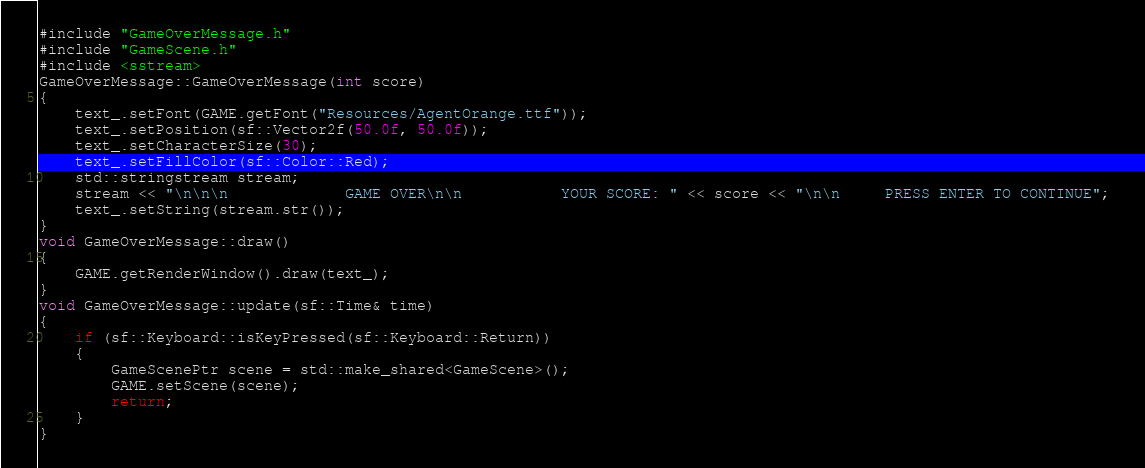<code> <loc_0><loc_0><loc_500><loc_500><_C++_>#include "GameOverMessage.h"
#include "GameScene.h"
#include <sstream>
GameOverMessage::GameOverMessage(int score)
{
	text_.setFont(GAME.getFont("Resources/AgentOrange.ttf"));
	text_.setPosition(sf::Vector2f(50.0f, 50.0f));
	text_.setCharacterSize(30);
	text_.setFillColor(sf::Color::Red);
	std::stringstream stream;
	stream << "\n\n\n             GAME OVER\n\n           YOUR SCORE: " << score << "\n\n     PRESS ENTER TO CONTINUE"; 
	text_.setString(stream.str());
}
void GameOverMessage::draw()
{
	GAME.getRenderWindow().draw(text_);
}
void GameOverMessage::update(sf::Time& time)
{
	if (sf::Keyboard::isKeyPressed(sf::Keyboard::Return))
	{
		GameScenePtr scene = std::make_shared<GameScene>();
		GAME.setScene(scene);
		return;
	}
}</code> 